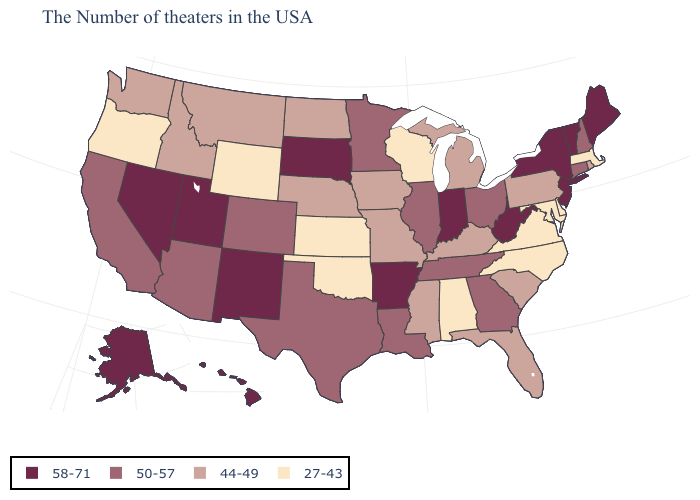Which states have the highest value in the USA?
Keep it brief. Maine, Vermont, New York, New Jersey, West Virginia, Indiana, Arkansas, South Dakota, New Mexico, Utah, Nevada, Alaska, Hawaii. What is the value of New Jersey?
Give a very brief answer. 58-71. Does Illinois have the lowest value in the USA?
Concise answer only. No. What is the value of Idaho?
Quick response, please. 44-49. Does Massachusetts have the lowest value in the Northeast?
Give a very brief answer. Yes. Does Utah have a higher value than California?
Write a very short answer. Yes. Does Wyoming have a lower value than Washington?
Write a very short answer. Yes. How many symbols are there in the legend?
Answer briefly. 4. Among the states that border Pennsylvania , does West Virginia have the highest value?
Be succinct. Yes. What is the value of Maine?
Keep it brief. 58-71. Name the states that have a value in the range 27-43?
Write a very short answer. Massachusetts, Delaware, Maryland, Virginia, North Carolina, Alabama, Wisconsin, Kansas, Oklahoma, Wyoming, Oregon. Name the states that have a value in the range 50-57?
Quick response, please. New Hampshire, Connecticut, Ohio, Georgia, Tennessee, Illinois, Louisiana, Minnesota, Texas, Colorado, Arizona, California. Which states have the highest value in the USA?
Short answer required. Maine, Vermont, New York, New Jersey, West Virginia, Indiana, Arkansas, South Dakota, New Mexico, Utah, Nevada, Alaska, Hawaii. What is the lowest value in the West?
Be succinct. 27-43. Does California have the highest value in the West?
Quick response, please. No. 